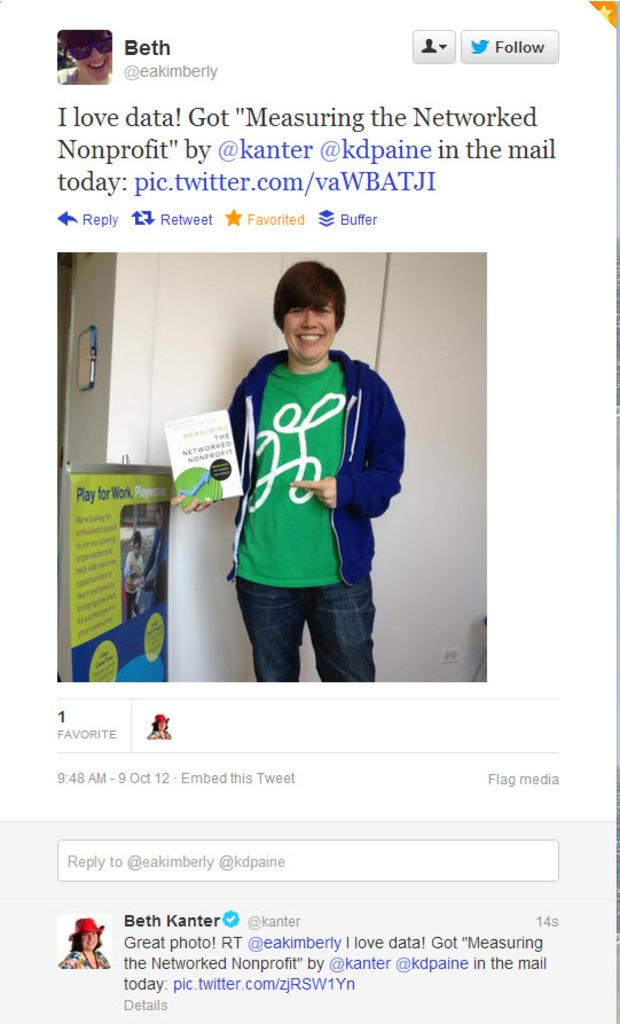How many times was this post favorited?
Provide a short and direct response. 1. What do they love?
Offer a very short reply. Data. 